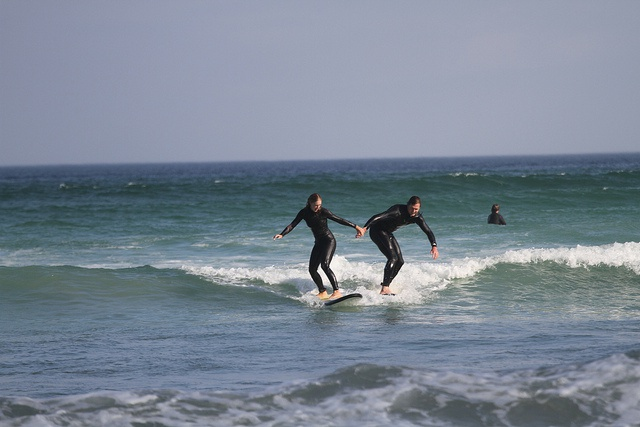Describe the objects in this image and their specific colors. I can see people in gray, black, darkgray, and lightgray tones, people in gray, black, and lightpink tones, surfboard in gray, black, and darkgray tones, people in gray, black, and purple tones, and surfboard in gray, lightgray, tan, and darkgray tones in this image. 